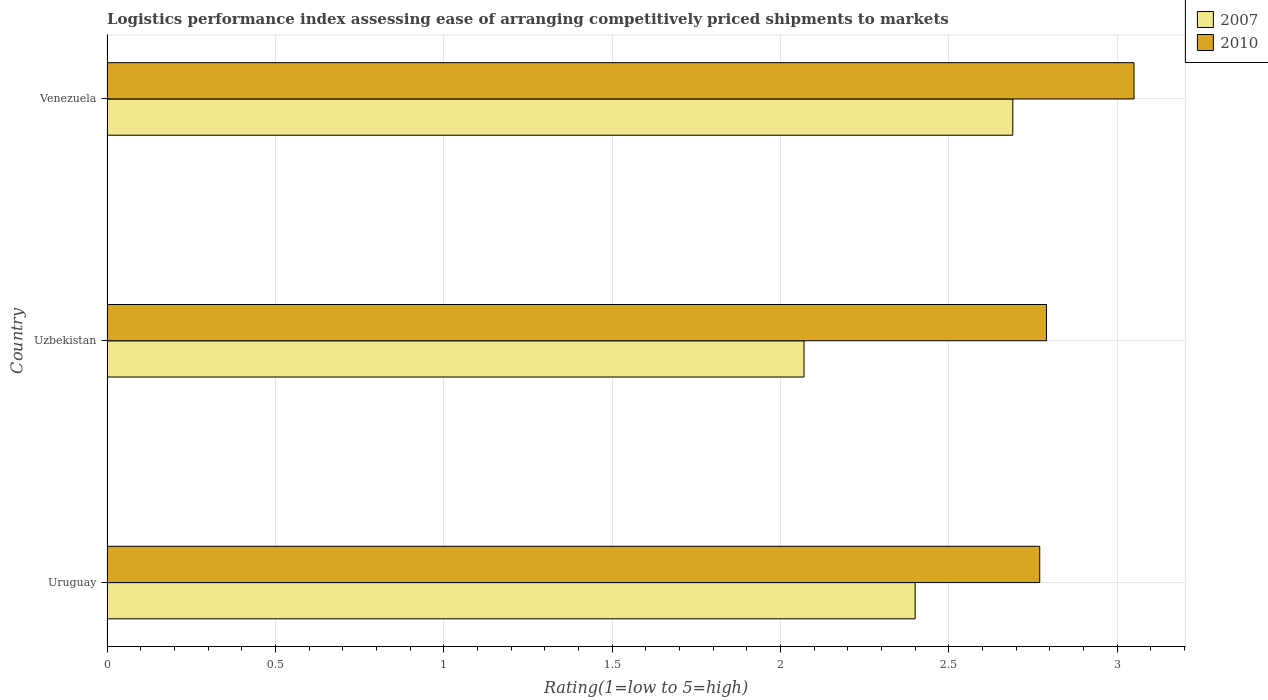How many groups of bars are there?
Make the answer very short. 3. Are the number of bars per tick equal to the number of legend labels?
Offer a very short reply. Yes. Are the number of bars on each tick of the Y-axis equal?
Make the answer very short. Yes. How many bars are there on the 2nd tick from the top?
Provide a short and direct response. 2. How many bars are there on the 1st tick from the bottom?
Give a very brief answer. 2. What is the label of the 2nd group of bars from the top?
Keep it short and to the point. Uzbekistan. What is the Logistic performance index in 2007 in Venezuela?
Ensure brevity in your answer.  2.69. Across all countries, what is the maximum Logistic performance index in 2007?
Offer a terse response. 2.69. Across all countries, what is the minimum Logistic performance index in 2010?
Make the answer very short. 2.77. In which country was the Logistic performance index in 2007 maximum?
Ensure brevity in your answer.  Venezuela. In which country was the Logistic performance index in 2010 minimum?
Your answer should be compact. Uruguay. What is the total Logistic performance index in 2010 in the graph?
Offer a terse response. 8.61. What is the difference between the Logistic performance index in 2010 in Uruguay and that in Venezuela?
Keep it short and to the point. -0.28. What is the difference between the Logistic performance index in 2010 in Uzbekistan and the Logistic performance index in 2007 in Uruguay?
Provide a succinct answer. 0.39. What is the average Logistic performance index in 2010 per country?
Your response must be concise. 2.87. What is the difference between the Logistic performance index in 2007 and Logistic performance index in 2010 in Uruguay?
Ensure brevity in your answer.  -0.37. In how many countries, is the Logistic performance index in 2007 greater than 2.5 ?
Keep it short and to the point. 1. What is the ratio of the Logistic performance index in 2007 in Uruguay to that in Venezuela?
Provide a succinct answer. 0.89. Is the difference between the Logistic performance index in 2007 in Uruguay and Uzbekistan greater than the difference between the Logistic performance index in 2010 in Uruguay and Uzbekistan?
Offer a very short reply. Yes. What is the difference between the highest and the second highest Logistic performance index in 2010?
Your answer should be compact. 0.26. What is the difference between the highest and the lowest Logistic performance index in 2010?
Offer a very short reply. 0.28. In how many countries, is the Logistic performance index in 2010 greater than the average Logistic performance index in 2010 taken over all countries?
Your answer should be very brief. 1. What does the 2nd bar from the top in Uruguay represents?
Offer a terse response. 2007. How many bars are there?
Make the answer very short. 6. How many countries are there in the graph?
Make the answer very short. 3. Are the values on the major ticks of X-axis written in scientific E-notation?
Give a very brief answer. No. Does the graph contain any zero values?
Keep it short and to the point. No. Where does the legend appear in the graph?
Your answer should be very brief. Top right. How are the legend labels stacked?
Your answer should be compact. Vertical. What is the title of the graph?
Provide a short and direct response. Logistics performance index assessing ease of arranging competitively priced shipments to markets. What is the label or title of the X-axis?
Offer a terse response. Rating(1=low to 5=high). What is the Rating(1=low to 5=high) of 2010 in Uruguay?
Ensure brevity in your answer.  2.77. What is the Rating(1=low to 5=high) of 2007 in Uzbekistan?
Offer a terse response. 2.07. What is the Rating(1=low to 5=high) of 2010 in Uzbekistan?
Make the answer very short. 2.79. What is the Rating(1=low to 5=high) in 2007 in Venezuela?
Your answer should be compact. 2.69. What is the Rating(1=low to 5=high) of 2010 in Venezuela?
Offer a terse response. 3.05. Across all countries, what is the maximum Rating(1=low to 5=high) of 2007?
Offer a terse response. 2.69. Across all countries, what is the maximum Rating(1=low to 5=high) of 2010?
Give a very brief answer. 3.05. Across all countries, what is the minimum Rating(1=low to 5=high) in 2007?
Make the answer very short. 2.07. Across all countries, what is the minimum Rating(1=low to 5=high) in 2010?
Keep it short and to the point. 2.77. What is the total Rating(1=low to 5=high) of 2007 in the graph?
Your answer should be very brief. 7.16. What is the total Rating(1=low to 5=high) of 2010 in the graph?
Your answer should be very brief. 8.61. What is the difference between the Rating(1=low to 5=high) of 2007 in Uruguay and that in Uzbekistan?
Ensure brevity in your answer.  0.33. What is the difference between the Rating(1=low to 5=high) in 2010 in Uruguay and that in Uzbekistan?
Your answer should be very brief. -0.02. What is the difference between the Rating(1=low to 5=high) of 2007 in Uruguay and that in Venezuela?
Your answer should be very brief. -0.29. What is the difference between the Rating(1=low to 5=high) of 2010 in Uruguay and that in Venezuela?
Make the answer very short. -0.28. What is the difference between the Rating(1=low to 5=high) of 2007 in Uzbekistan and that in Venezuela?
Keep it short and to the point. -0.62. What is the difference between the Rating(1=low to 5=high) of 2010 in Uzbekistan and that in Venezuela?
Your answer should be compact. -0.26. What is the difference between the Rating(1=low to 5=high) of 2007 in Uruguay and the Rating(1=low to 5=high) of 2010 in Uzbekistan?
Your response must be concise. -0.39. What is the difference between the Rating(1=low to 5=high) in 2007 in Uruguay and the Rating(1=low to 5=high) in 2010 in Venezuela?
Give a very brief answer. -0.65. What is the difference between the Rating(1=low to 5=high) of 2007 in Uzbekistan and the Rating(1=low to 5=high) of 2010 in Venezuela?
Your answer should be very brief. -0.98. What is the average Rating(1=low to 5=high) of 2007 per country?
Offer a terse response. 2.39. What is the average Rating(1=low to 5=high) of 2010 per country?
Ensure brevity in your answer.  2.87. What is the difference between the Rating(1=low to 5=high) of 2007 and Rating(1=low to 5=high) of 2010 in Uruguay?
Provide a succinct answer. -0.37. What is the difference between the Rating(1=low to 5=high) of 2007 and Rating(1=low to 5=high) of 2010 in Uzbekistan?
Make the answer very short. -0.72. What is the difference between the Rating(1=low to 5=high) of 2007 and Rating(1=low to 5=high) of 2010 in Venezuela?
Your answer should be very brief. -0.36. What is the ratio of the Rating(1=low to 5=high) of 2007 in Uruguay to that in Uzbekistan?
Offer a terse response. 1.16. What is the ratio of the Rating(1=low to 5=high) of 2007 in Uruguay to that in Venezuela?
Your answer should be very brief. 0.89. What is the ratio of the Rating(1=low to 5=high) of 2010 in Uruguay to that in Venezuela?
Provide a succinct answer. 0.91. What is the ratio of the Rating(1=low to 5=high) in 2007 in Uzbekistan to that in Venezuela?
Your response must be concise. 0.77. What is the ratio of the Rating(1=low to 5=high) of 2010 in Uzbekistan to that in Venezuela?
Your response must be concise. 0.91. What is the difference between the highest and the second highest Rating(1=low to 5=high) in 2007?
Your response must be concise. 0.29. What is the difference between the highest and the second highest Rating(1=low to 5=high) of 2010?
Ensure brevity in your answer.  0.26. What is the difference between the highest and the lowest Rating(1=low to 5=high) in 2007?
Your response must be concise. 0.62. What is the difference between the highest and the lowest Rating(1=low to 5=high) of 2010?
Make the answer very short. 0.28. 